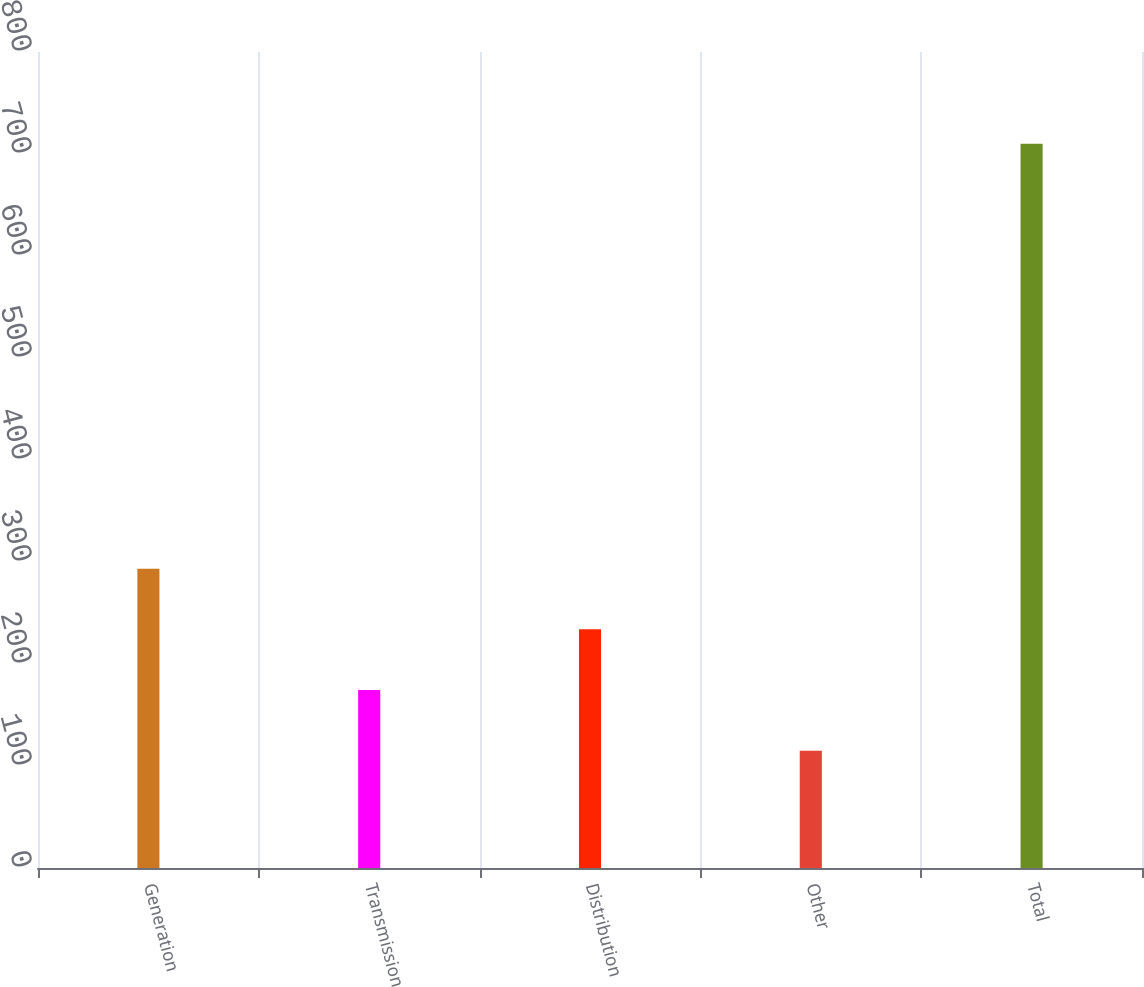Convert chart to OTSL. <chart><loc_0><loc_0><loc_500><loc_500><bar_chart><fcel>Generation<fcel>Transmission<fcel>Distribution<fcel>Other<fcel>Total<nl><fcel>293.5<fcel>174.5<fcel>234<fcel>115<fcel>710<nl></chart> 